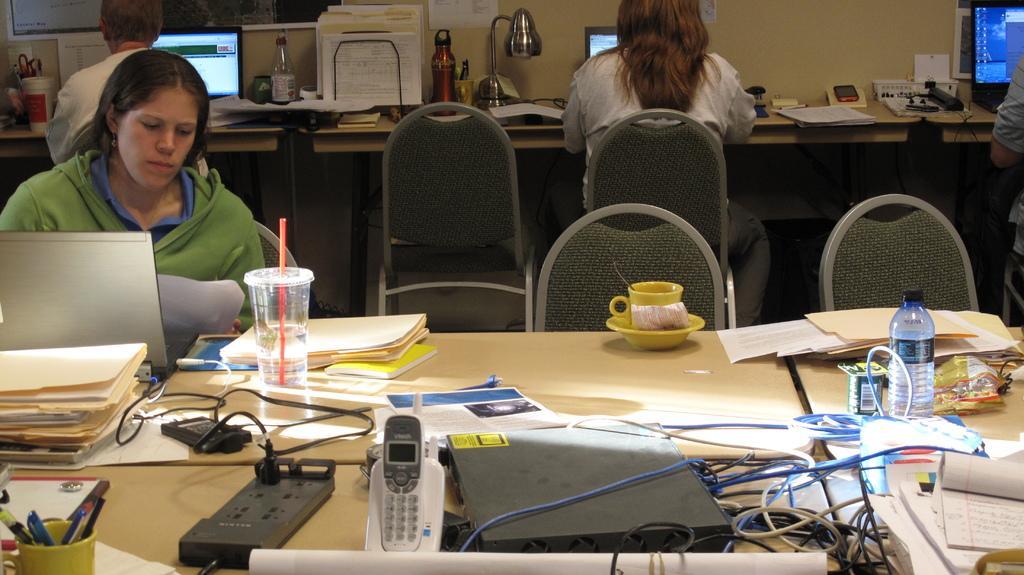Please provide a concise description of this image. As we can see in the image there is a wall, four people sitting on chairs and there are tables. On table there is a switch board, papers, glass, cup, bottles, wires, telephone, pens and there is a lamp. On table there are few laptops. 